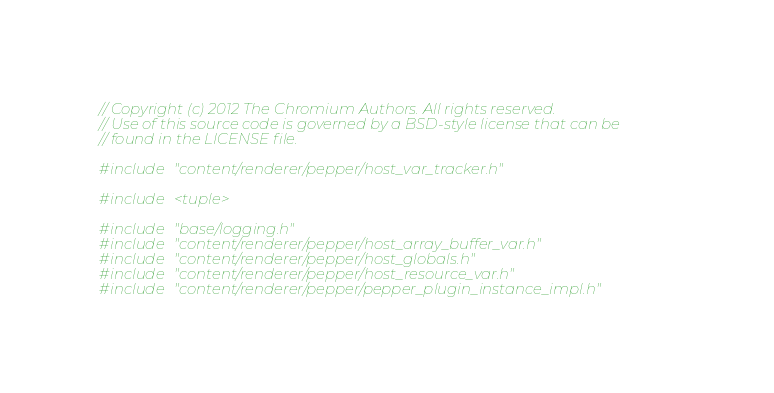Convert code to text. <code><loc_0><loc_0><loc_500><loc_500><_C++_>// Copyright (c) 2012 The Chromium Authors. All rights reserved.
// Use of this source code is governed by a BSD-style license that can be
// found in the LICENSE file.

#include "content/renderer/pepper/host_var_tracker.h"

#include <tuple>

#include "base/logging.h"
#include "content/renderer/pepper/host_array_buffer_var.h"
#include "content/renderer/pepper/host_globals.h"
#include "content/renderer/pepper/host_resource_var.h"
#include "content/renderer/pepper/pepper_plugin_instance_impl.h"</code> 